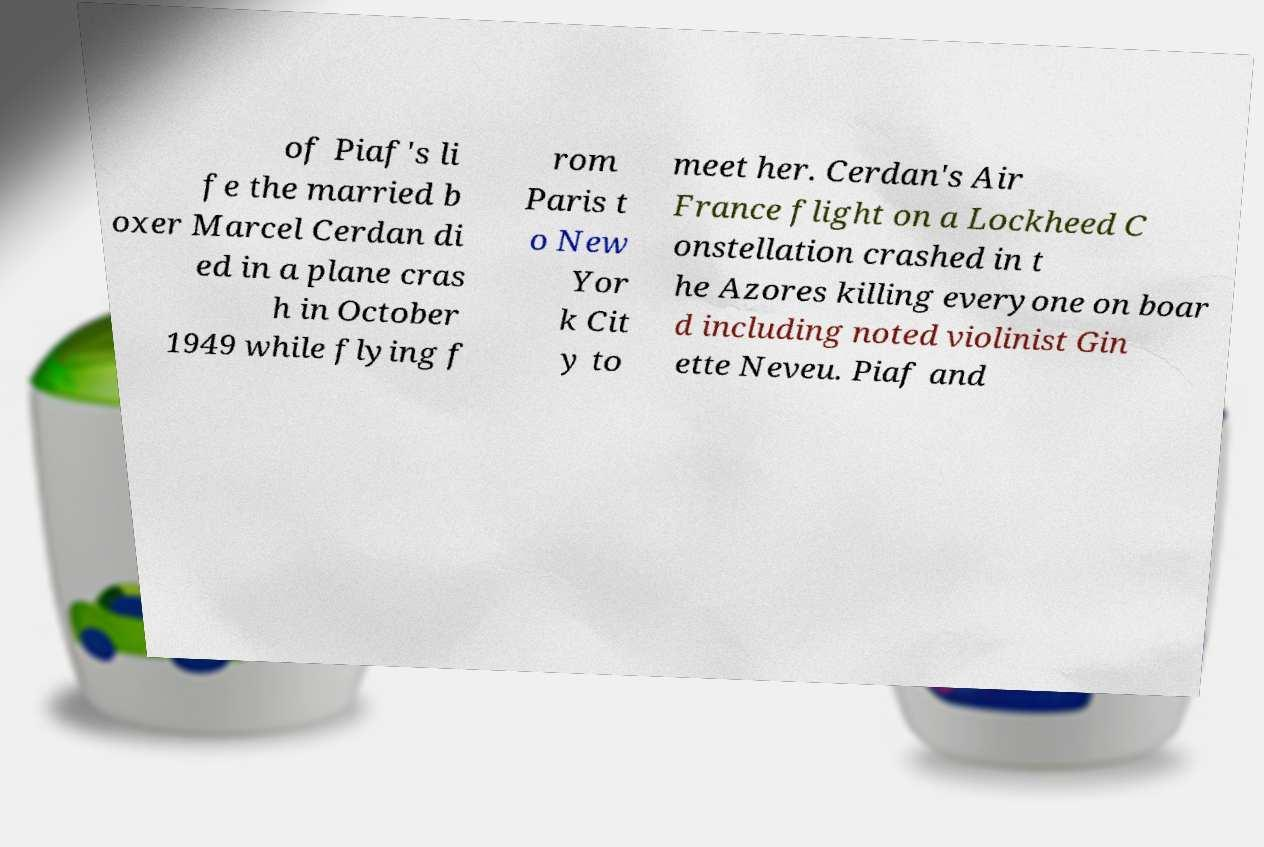Can you read and provide the text displayed in the image?This photo seems to have some interesting text. Can you extract and type it out for me? of Piaf's li fe the married b oxer Marcel Cerdan di ed in a plane cras h in October 1949 while flying f rom Paris t o New Yor k Cit y to meet her. Cerdan's Air France flight on a Lockheed C onstellation crashed in t he Azores killing everyone on boar d including noted violinist Gin ette Neveu. Piaf and 